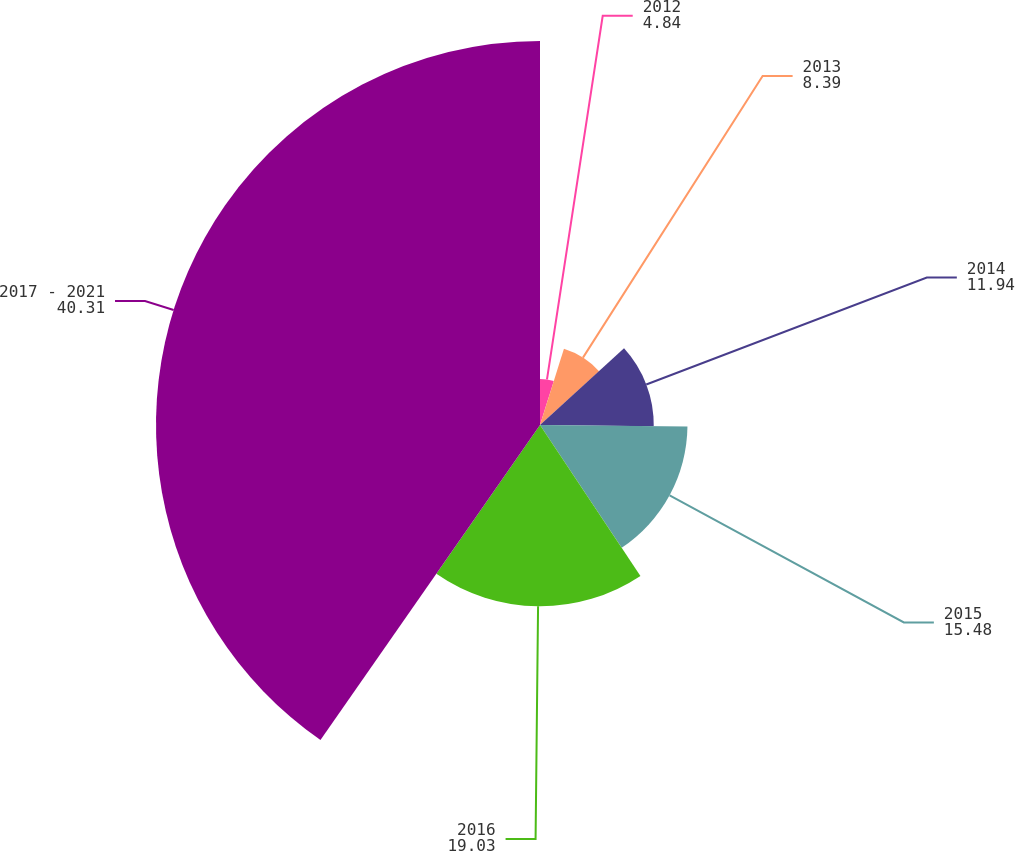Convert chart. <chart><loc_0><loc_0><loc_500><loc_500><pie_chart><fcel>2012<fcel>2013<fcel>2014<fcel>2015<fcel>2016<fcel>2017 - 2021<nl><fcel>4.84%<fcel>8.39%<fcel>11.94%<fcel>15.48%<fcel>19.03%<fcel>40.31%<nl></chart> 